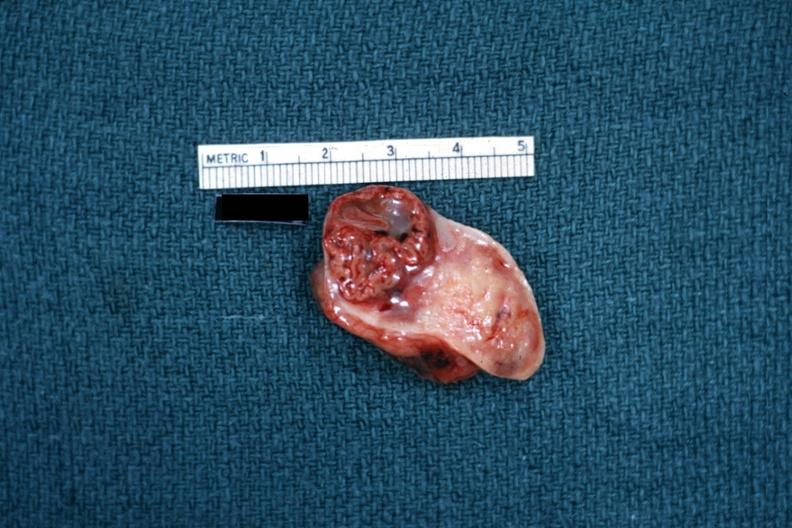where does this belong to?
Answer the question using a single word or phrase. Female reproductive system 